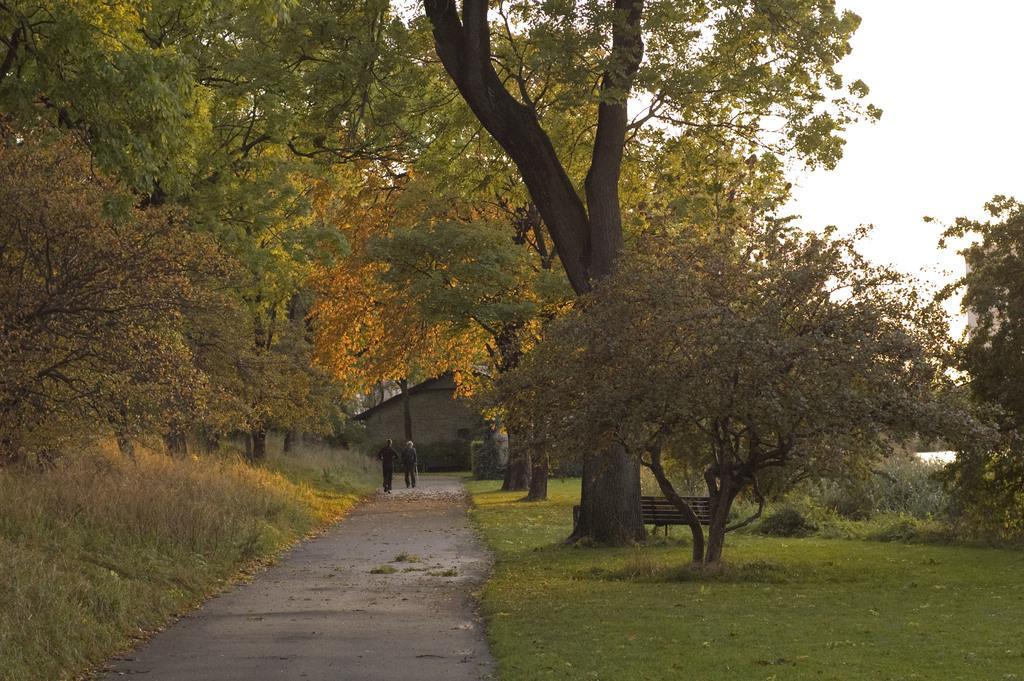How would you summarize this image in a sentence or two? In this picture I can see trees, few plants, a bench and grass on the ground. I can see couple of them walking and a house in the back. I can see a cloudy sky. 